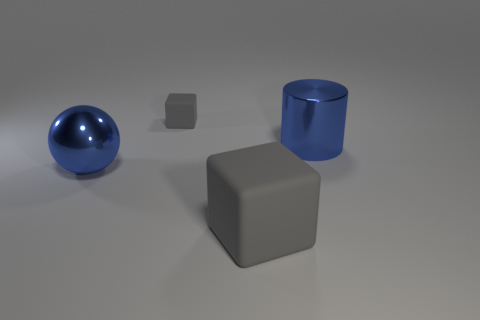What time of day does the lighting in the scene suggest? The lighting in the scene doesn't strongly indicate a specific time of day as it appears to be a controlled studio setting with a neutral, diffused light source, possibly simulating an overcast sky or soft indoor lighting. 